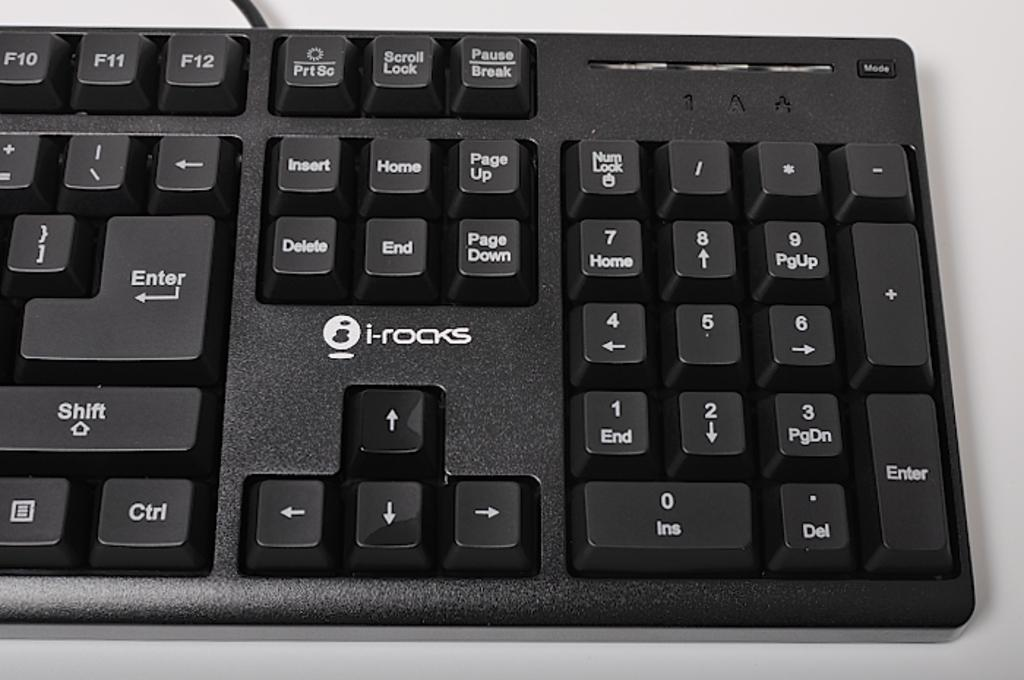<image>
Render a clear and concise summary of the photo. a keyboard with the word i-rocks on it above the arrows 